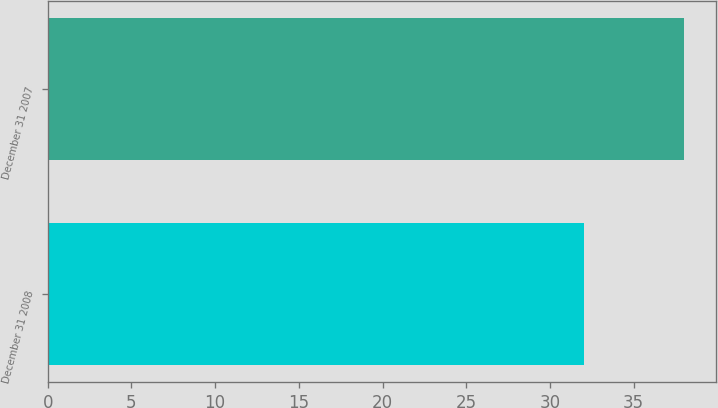<chart> <loc_0><loc_0><loc_500><loc_500><bar_chart><fcel>December 31 2008<fcel>December 31 2007<nl><fcel>32<fcel>38<nl></chart> 